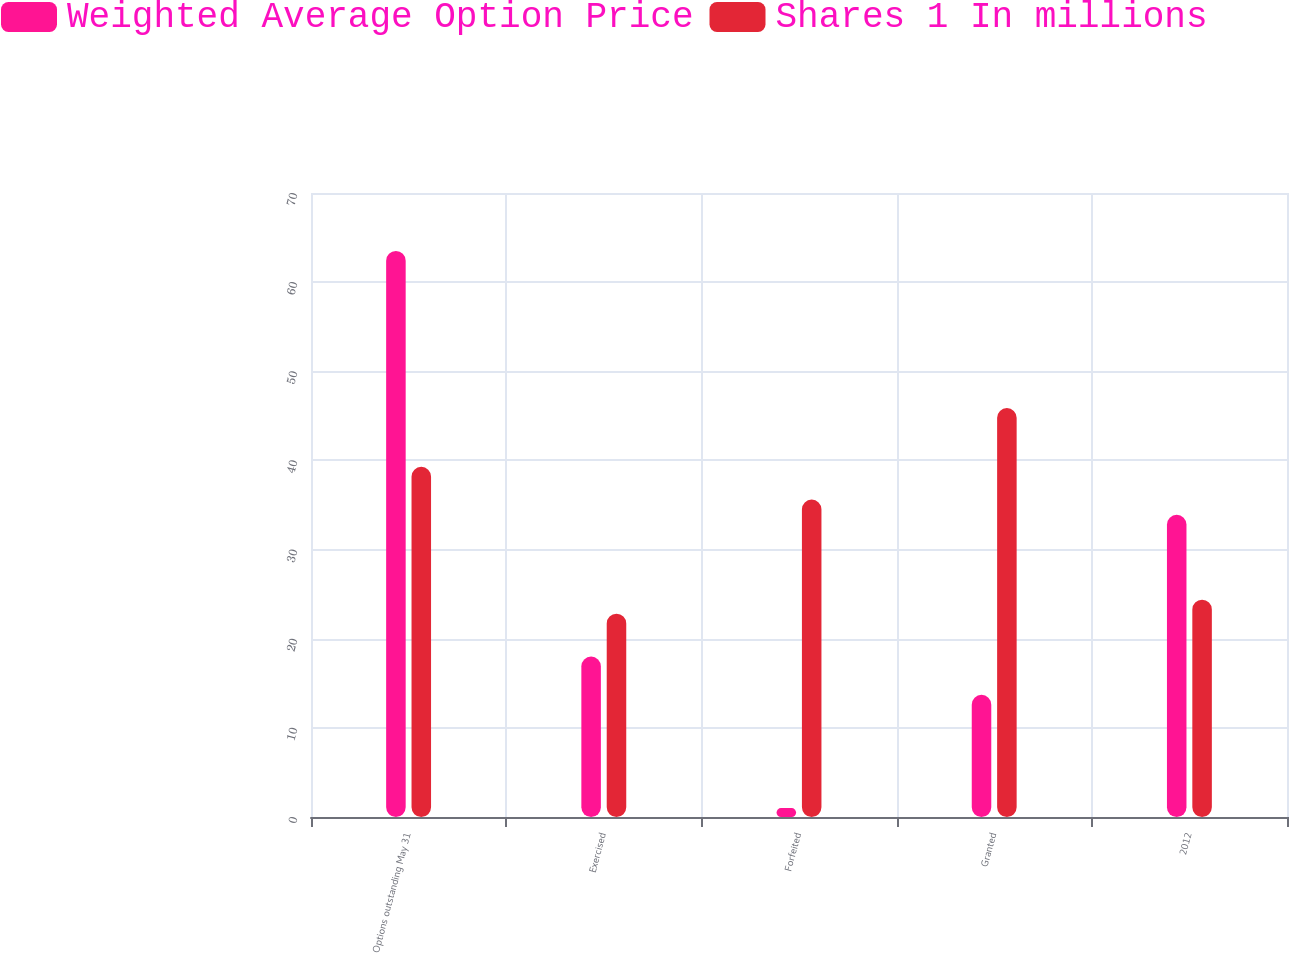Convert chart. <chart><loc_0><loc_0><loc_500><loc_500><stacked_bar_chart><ecel><fcel>Options outstanding May 31<fcel>Exercised<fcel>Forfeited<fcel>Granted<fcel>2012<nl><fcel>Weighted Average Option Price<fcel>63.5<fcel>18<fcel>1<fcel>13.7<fcel>33.9<nl><fcel>Shares 1 In millions<fcel>39.28<fcel>22.81<fcel>35.61<fcel>45.87<fcel>24.38<nl></chart> 